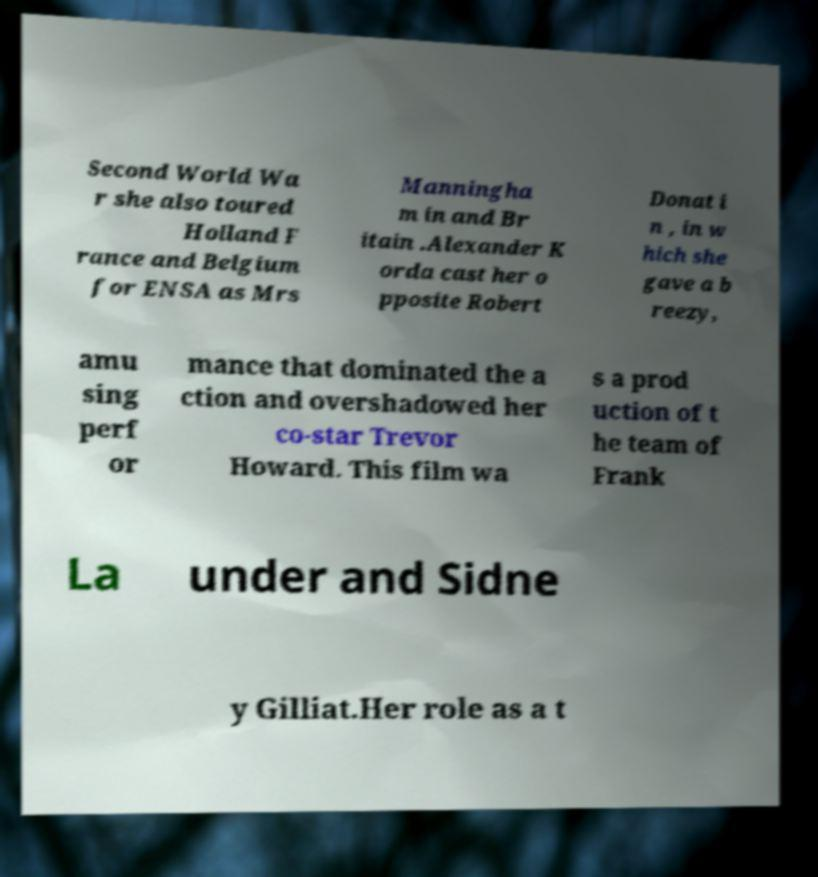Can you accurately transcribe the text from the provided image for me? Second World Wa r she also toured Holland F rance and Belgium for ENSA as Mrs Manningha m in and Br itain .Alexander K orda cast her o pposite Robert Donat i n , in w hich she gave a b reezy, amu sing perf or mance that dominated the a ction and overshadowed her co-star Trevor Howard. This film wa s a prod uction of t he team of Frank La under and Sidne y Gilliat.Her role as a t 